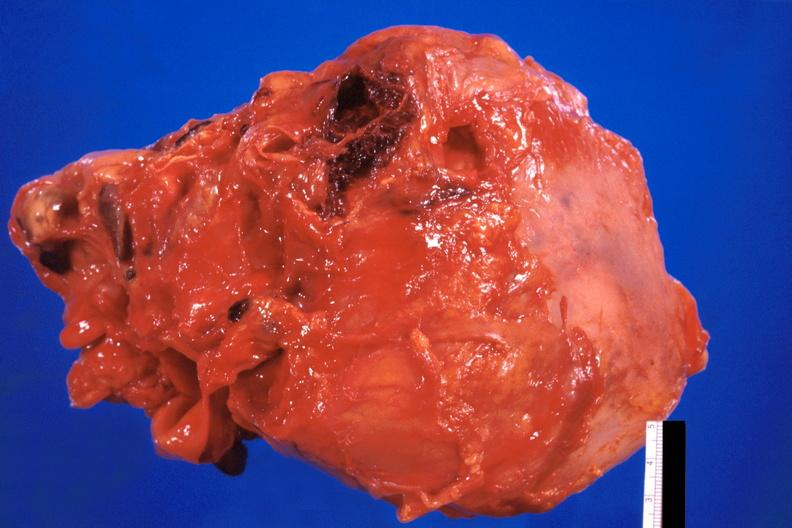s cardiovascular present?
Answer the question using a single word or phrase. Yes 